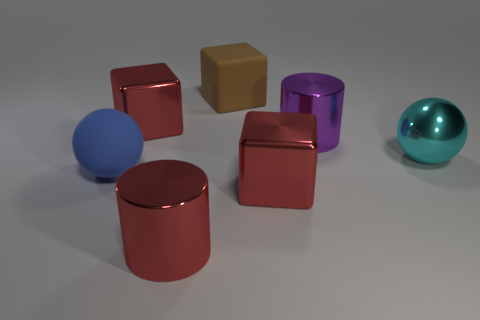There is a shiny object right of the purple shiny cylinder; is it the same size as the matte block?
Keep it short and to the point. Yes. What number of large brown objects are in front of the purple thing?
Provide a short and direct response. 0. Is there a brown matte cube that has the same size as the purple shiny thing?
Give a very brief answer. Yes. What color is the metallic cylinder on the left side of the big rubber object behind the large blue matte thing?
Make the answer very short. Red. How many large objects are left of the large cyan metallic object and in front of the brown block?
Offer a very short reply. 5. How many other rubber things have the same shape as the blue object?
Your answer should be very brief. 0. Is the big blue sphere made of the same material as the brown block?
Provide a succinct answer. Yes. What shape is the red object that is in front of the red metallic cube that is right of the large brown object?
Make the answer very short. Cylinder. How many large metallic cubes are on the left side of the big red block in front of the matte ball?
Provide a succinct answer. 1. What is the thing that is left of the large red cylinder and behind the large purple shiny cylinder made of?
Ensure brevity in your answer.  Metal. 